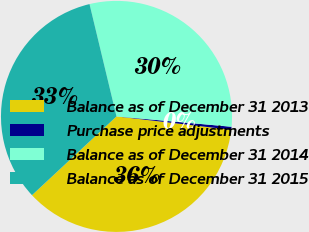<chart> <loc_0><loc_0><loc_500><loc_500><pie_chart><fcel>Balance as of December 31 2013<fcel>Purchase price adjustments<fcel>Balance as of December 31 2014<fcel>Balance as of December 31 2015<nl><fcel>36.21%<fcel>0.42%<fcel>30.18%<fcel>33.19%<nl></chart> 